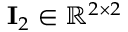<formula> <loc_0><loc_0><loc_500><loc_500>I _ { 2 } \in \mathbb { R } ^ { 2 \times 2 }</formula> 